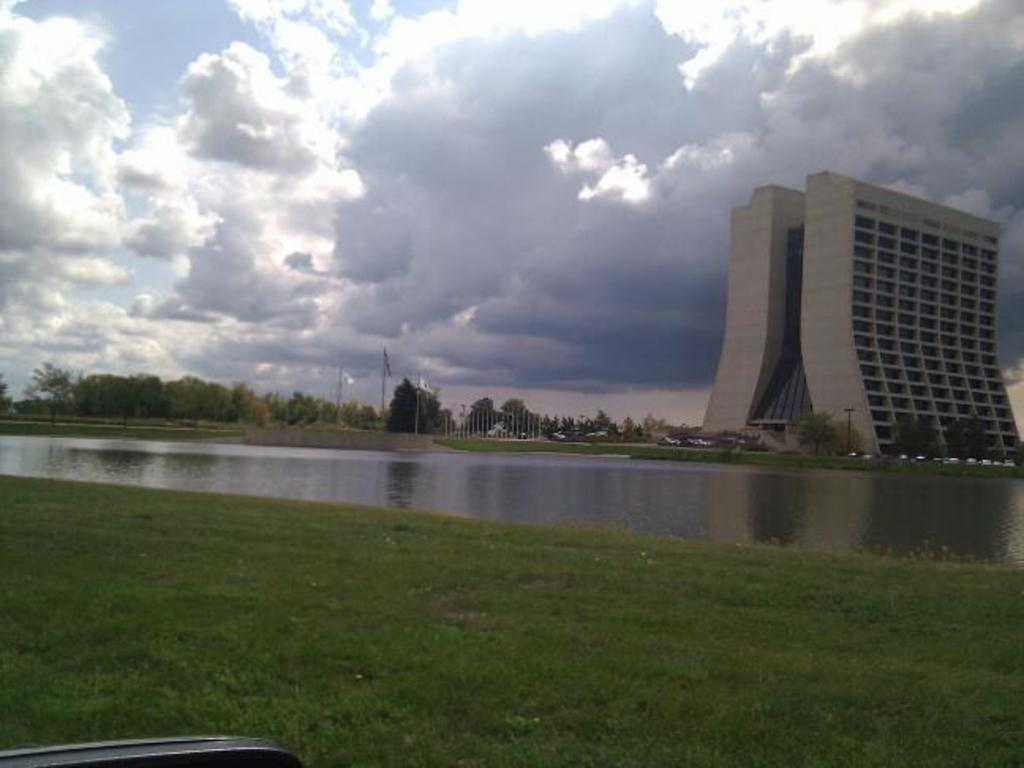What type of body of water is in front of the building? There is a lake in front of the building. What is covering the ground around the lake and building? There is grass on the ground. What can be seen in the sky in the image? There are clouds in the sky. What type of basket is hanging from the clouds in the image? There is no basket present in the image; it only features a lake, a building, grass, and clouds. How many combs can be seen in the grass near the lake? There are no combs present in the image; it only features a lake, a building, grass, and clouds. 